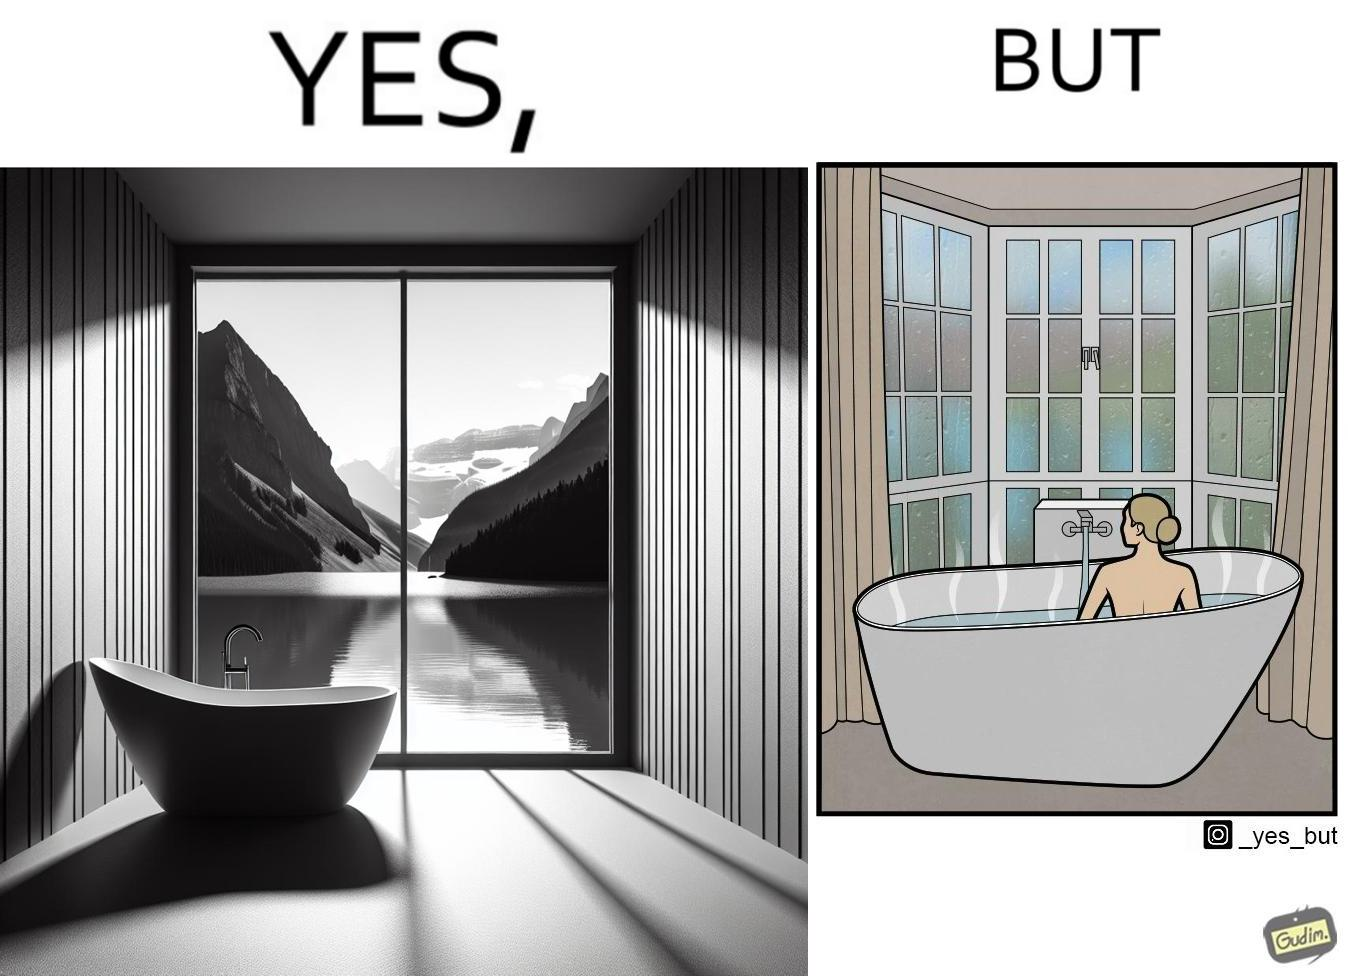Explain the humor or irony in this image. The image is ironical, as a bathtub near a window having a very scenic view, becomes misty when someone is bathing, thus making the scenic view blurry. 